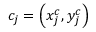Convert formula to latex. <formula><loc_0><loc_0><loc_500><loc_500>c _ { j } = \left ( x _ { j } ^ { c } , y _ { j } ^ { c } \right )</formula> 